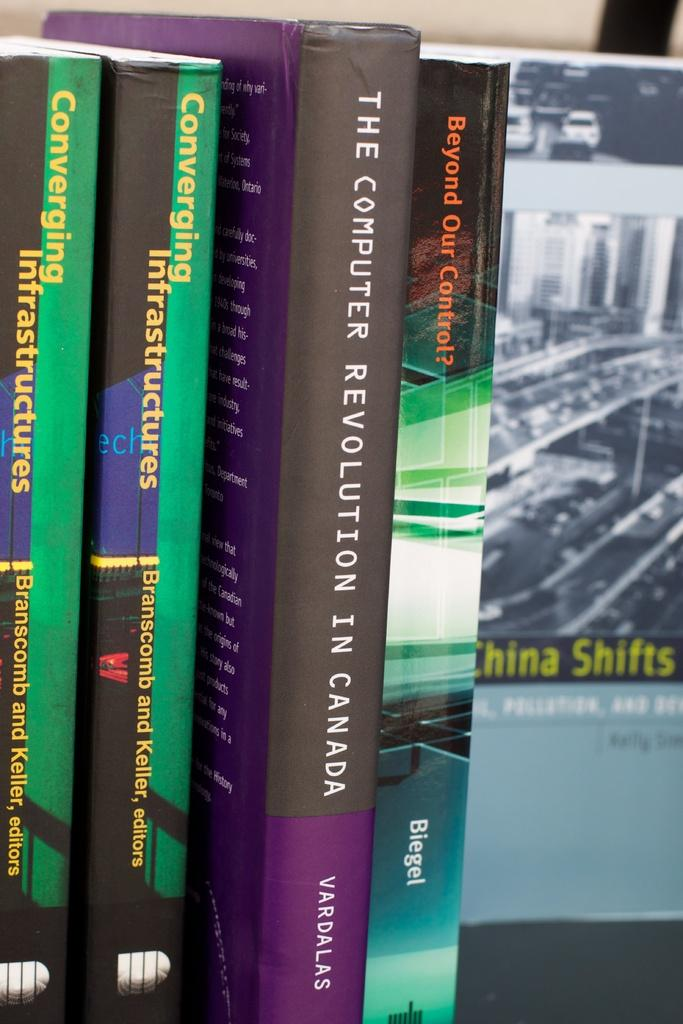Provide a one-sentence caption for the provided image. A purple book titled The computer revolution in Canada. 